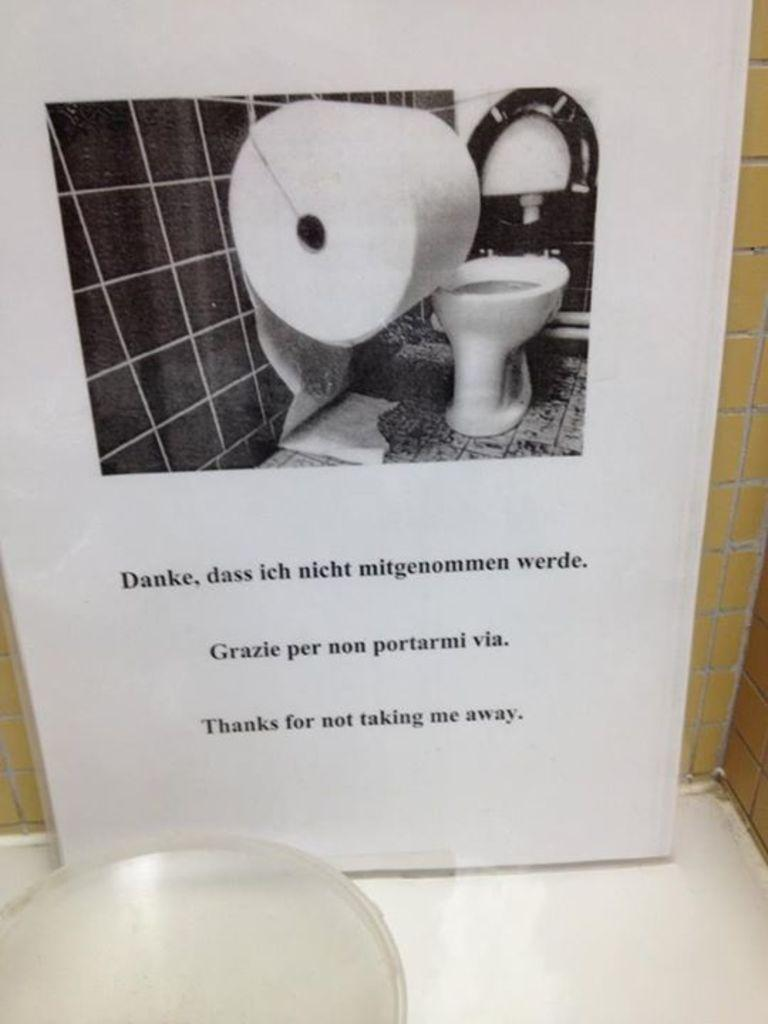What is the main subject of the board in the image? The main subject of the board in the image is an image of a toilet. What other image is present on the board? There is an image of a paper roll on the board. What is written or depicted on the board? There is text on the board, but the specific content is not mentioned in the facts. What object can be seen on the floor in the image? There is an object on the floor in the image, but its description is not provided in the facts. What type of punishment is being depicted on the playground in the image? There is no playground or punishment depicted in the image; it features a board with images of a toilet and a paper roll, along with text and an object on the floor. 